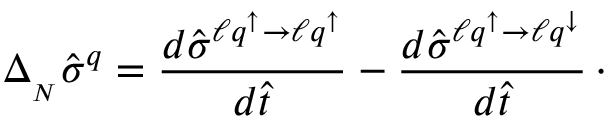<formula> <loc_0><loc_0><loc_500><loc_500>\Delta _ { _ { N } } \hat { \sigma } ^ { q } = { \frac { d \hat { \sigma } ^ { \ell q ^ { \uparrow } \to \ell q ^ { \uparrow } } } { d \hat { t } } } - { \frac { d \hat { \sigma } ^ { \ell q ^ { \uparrow } \to \ell q ^ { \downarrow } } } { d \hat { t } } } \, \cdot</formula> 